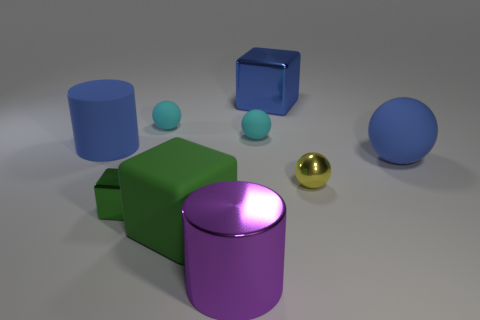Subtract all green balls. Subtract all green cubes. How many balls are left? 4 Subtract all blocks. How many objects are left? 6 Add 5 metallic cylinders. How many metallic cylinders are left? 6 Add 4 large cylinders. How many large cylinders exist? 6 Subtract 0 gray cubes. How many objects are left? 9 Subtract all yellow metallic spheres. Subtract all small red metal things. How many objects are left? 8 